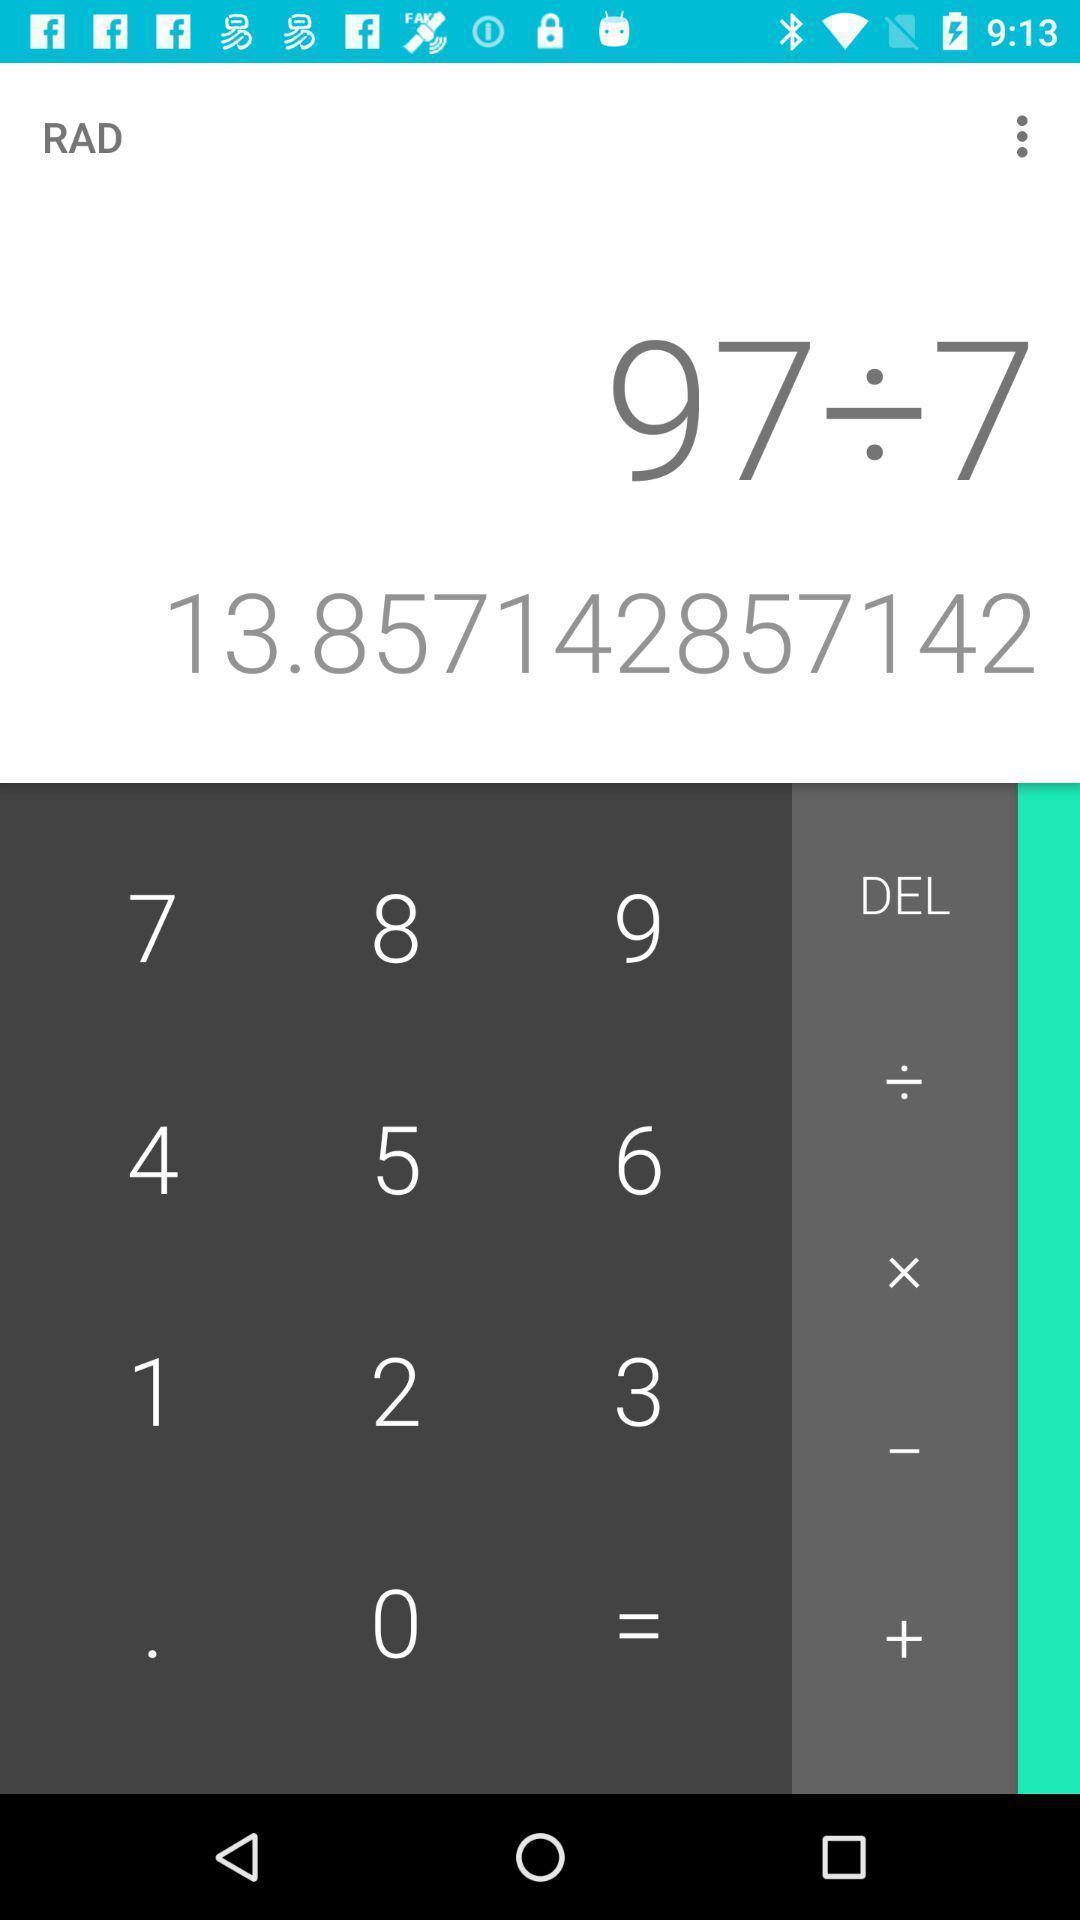What is the overall content of this screenshot? Screen displaying the calculator app. 